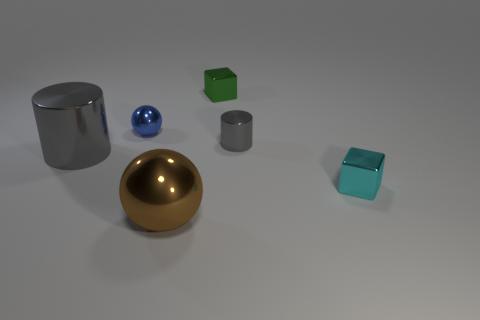Add 3 cyan metallic cubes. How many objects exist? 9 Subtract all cylinders. How many objects are left? 4 Add 1 small green blocks. How many small green blocks exist? 2 Subtract 0 yellow spheres. How many objects are left? 6 Subtract all yellow rubber objects. Subtract all large metal balls. How many objects are left? 5 Add 5 small metallic things. How many small metallic things are left? 9 